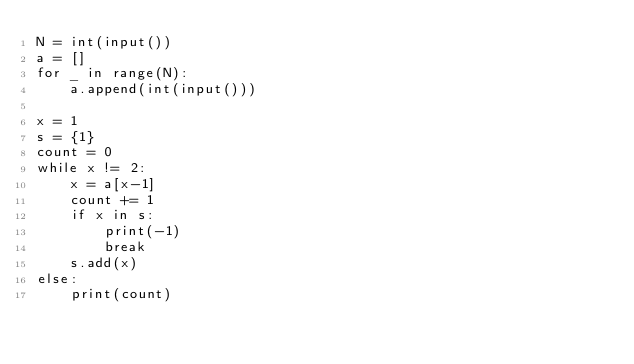<code> <loc_0><loc_0><loc_500><loc_500><_Python_>N = int(input())
a = []
for _ in range(N):
    a.append(int(input()))

x = 1
s = {1}
count = 0
while x != 2:
    x = a[x-1]
    count += 1
    if x in s:
        print(-1)
        break
    s.add(x)
else:
    print(count)</code> 